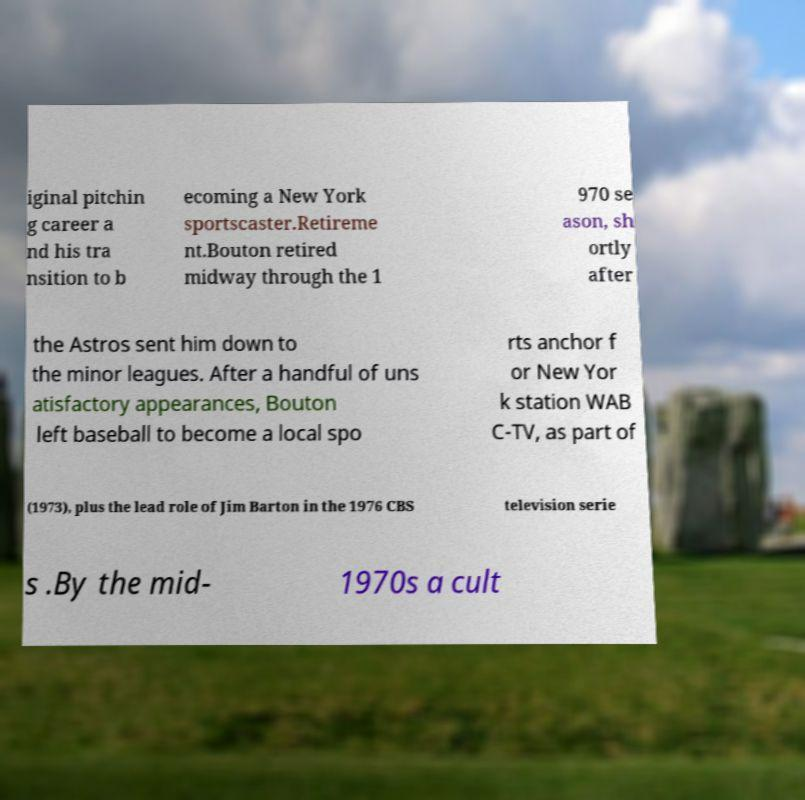Could you assist in decoding the text presented in this image and type it out clearly? iginal pitchin g career a nd his tra nsition to b ecoming a New York sportscaster.Retireme nt.Bouton retired midway through the 1 970 se ason, sh ortly after the Astros sent him down to the minor leagues. After a handful of uns atisfactory appearances, Bouton left baseball to become a local spo rts anchor f or New Yor k station WAB C-TV, as part of (1973), plus the lead role of Jim Barton in the 1976 CBS television serie s .By the mid- 1970s a cult 